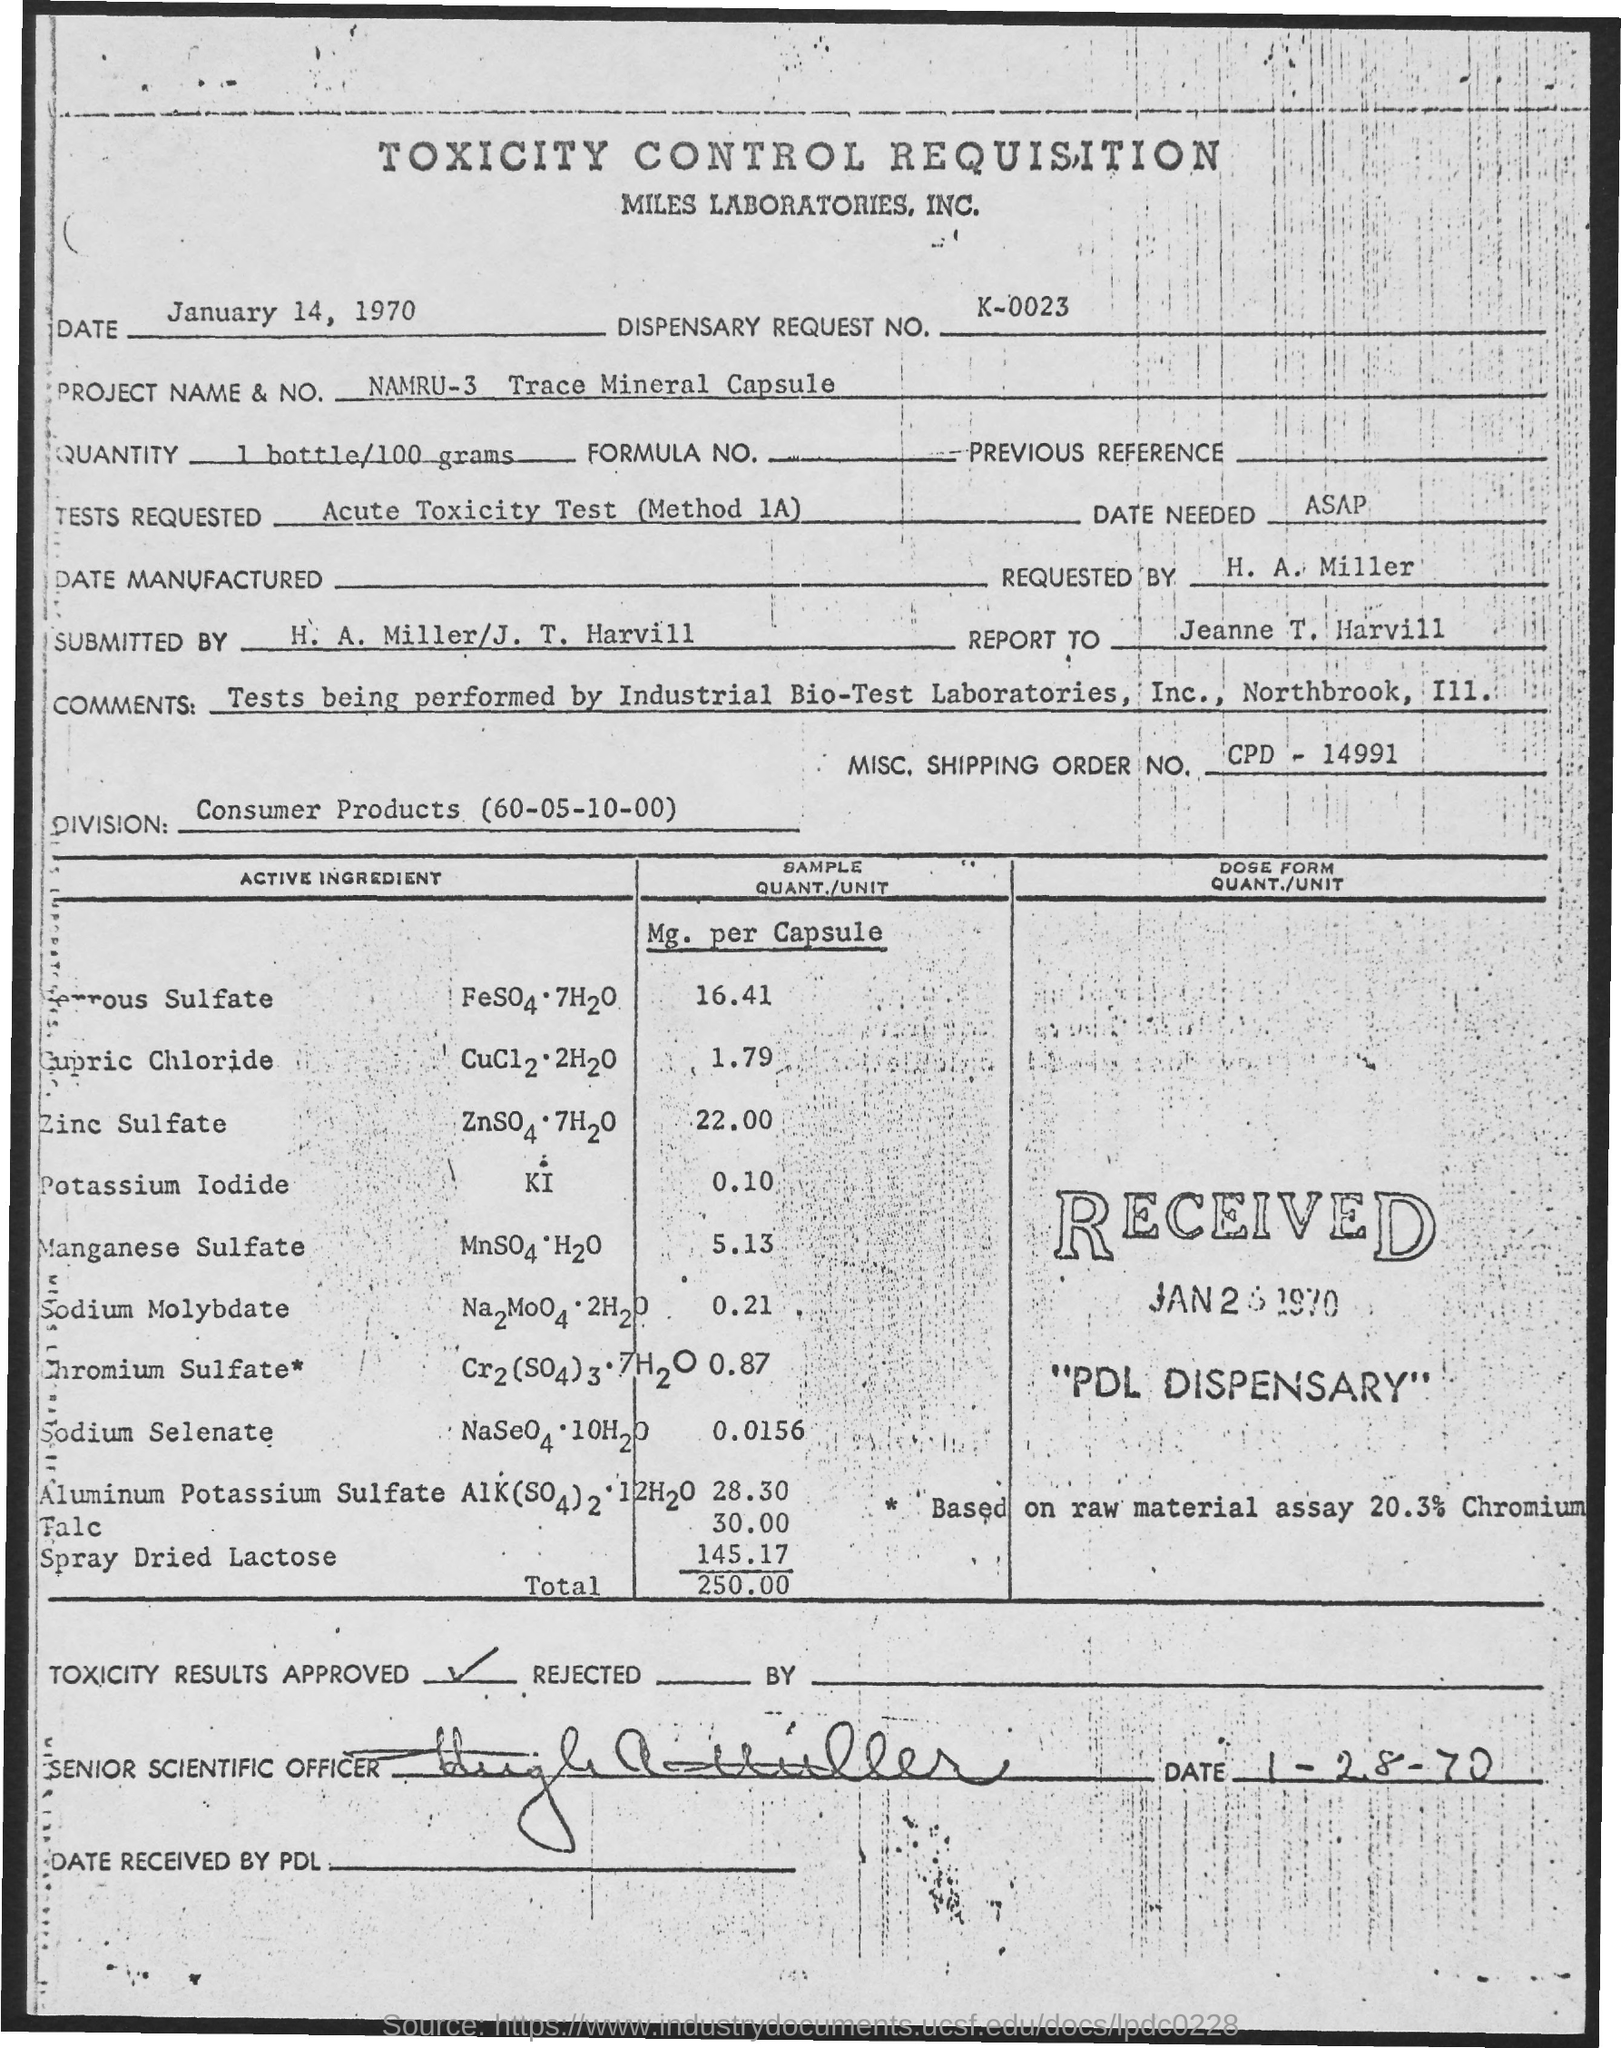What is the title of the document?
Give a very brief answer. Toxicity control requisition. What is the dispensary Request Number?
Your answer should be compact. K-0023. What is the Project Name & No.?
Your answer should be compact. Namru-3 trace mineral capsule. What is the Misc.Shipping Order No.?
Make the answer very short. CPD - 14991. What is the name of the division?
Your answer should be compact. Consumer Products (60-05-10-00). 